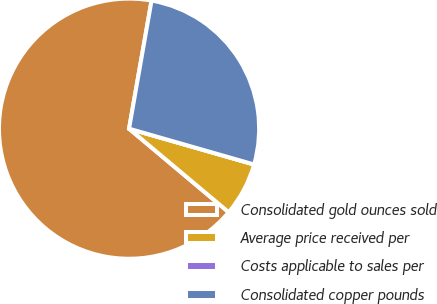<chart> <loc_0><loc_0><loc_500><loc_500><pie_chart><fcel>Consolidated gold ounces sold<fcel>Average price received per<fcel>Costs applicable to sales per<fcel>Consolidated copper pounds<nl><fcel>66.66%<fcel>6.67%<fcel>0.0%<fcel>26.67%<nl></chart> 